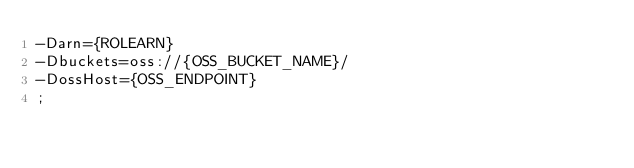<code> <loc_0><loc_0><loc_500><loc_500><_SQL_>-Darn={ROLEARN}
-Dbuckets=oss://{OSS_BUCKET_NAME}/
-DossHost={OSS_ENDPOINT}
;
</code> 